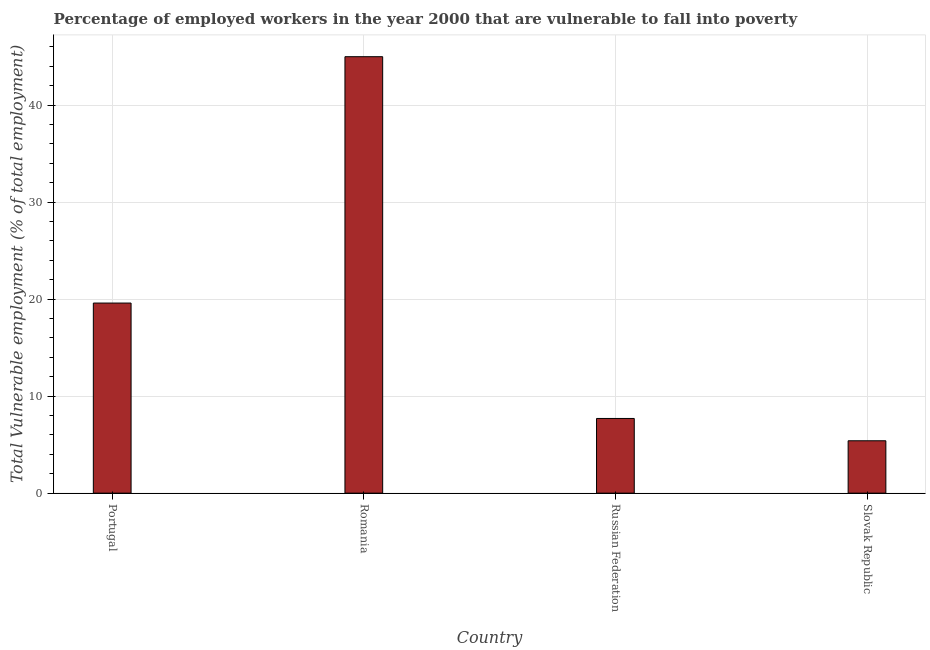Does the graph contain any zero values?
Keep it short and to the point. No. Does the graph contain grids?
Provide a short and direct response. Yes. What is the title of the graph?
Make the answer very short. Percentage of employed workers in the year 2000 that are vulnerable to fall into poverty. What is the label or title of the X-axis?
Offer a terse response. Country. What is the label or title of the Y-axis?
Provide a short and direct response. Total Vulnerable employment (% of total employment). What is the total vulnerable employment in Portugal?
Keep it short and to the point. 19.6. Across all countries, what is the minimum total vulnerable employment?
Your answer should be compact. 5.4. In which country was the total vulnerable employment maximum?
Your response must be concise. Romania. In which country was the total vulnerable employment minimum?
Your answer should be very brief. Slovak Republic. What is the sum of the total vulnerable employment?
Your answer should be compact. 77.7. What is the difference between the total vulnerable employment in Portugal and Romania?
Ensure brevity in your answer.  -25.4. What is the average total vulnerable employment per country?
Keep it short and to the point. 19.43. What is the median total vulnerable employment?
Provide a succinct answer. 13.65. In how many countries, is the total vulnerable employment greater than 38 %?
Your response must be concise. 1. What is the ratio of the total vulnerable employment in Portugal to that in Romania?
Ensure brevity in your answer.  0.44. What is the difference between the highest and the second highest total vulnerable employment?
Make the answer very short. 25.4. Is the sum of the total vulnerable employment in Romania and Slovak Republic greater than the maximum total vulnerable employment across all countries?
Keep it short and to the point. Yes. What is the difference between the highest and the lowest total vulnerable employment?
Offer a terse response. 39.6. In how many countries, is the total vulnerable employment greater than the average total vulnerable employment taken over all countries?
Your response must be concise. 2. How many bars are there?
Your response must be concise. 4. How many countries are there in the graph?
Ensure brevity in your answer.  4. What is the difference between two consecutive major ticks on the Y-axis?
Provide a succinct answer. 10. Are the values on the major ticks of Y-axis written in scientific E-notation?
Provide a short and direct response. No. What is the Total Vulnerable employment (% of total employment) of Portugal?
Provide a short and direct response. 19.6. What is the Total Vulnerable employment (% of total employment) of Romania?
Your response must be concise. 45. What is the Total Vulnerable employment (% of total employment) of Russian Federation?
Make the answer very short. 7.7. What is the Total Vulnerable employment (% of total employment) in Slovak Republic?
Provide a succinct answer. 5.4. What is the difference between the Total Vulnerable employment (% of total employment) in Portugal and Romania?
Give a very brief answer. -25.4. What is the difference between the Total Vulnerable employment (% of total employment) in Romania and Russian Federation?
Make the answer very short. 37.3. What is the difference between the Total Vulnerable employment (% of total employment) in Romania and Slovak Republic?
Offer a terse response. 39.6. What is the ratio of the Total Vulnerable employment (% of total employment) in Portugal to that in Romania?
Provide a short and direct response. 0.44. What is the ratio of the Total Vulnerable employment (% of total employment) in Portugal to that in Russian Federation?
Offer a terse response. 2.54. What is the ratio of the Total Vulnerable employment (% of total employment) in Portugal to that in Slovak Republic?
Provide a short and direct response. 3.63. What is the ratio of the Total Vulnerable employment (% of total employment) in Romania to that in Russian Federation?
Your answer should be very brief. 5.84. What is the ratio of the Total Vulnerable employment (% of total employment) in Romania to that in Slovak Republic?
Offer a very short reply. 8.33. What is the ratio of the Total Vulnerable employment (% of total employment) in Russian Federation to that in Slovak Republic?
Offer a very short reply. 1.43. 